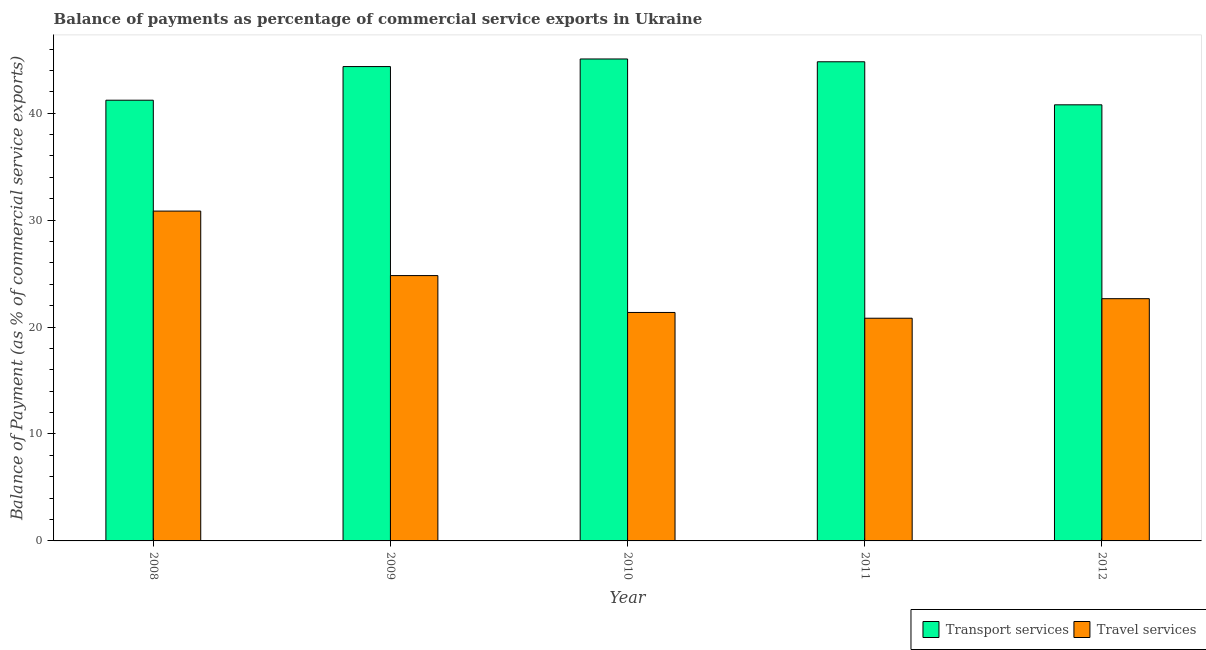How many groups of bars are there?
Offer a very short reply. 5. Are the number of bars on each tick of the X-axis equal?
Provide a succinct answer. Yes. In how many cases, is the number of bars for a given year not equal to the number of legend labels?
Offer a terse response. 0. What is the balance of payments of travel services in 2009?
Offer a very short reply. 24.81. Across all years, what is the maximum balance of payments of travel services?
Your response must be concise. 30.85. Across all years, what is the minimum balance of payments of transport services?
Your answer should be very brief. 40.79. In which year was the balance of payments of transport services maximum?
Provide a succinct answer. 2010. In which year was the balance of payments of transport services minimum?
Give a very brief answer. 2012. What is the total balance of payments of travel services in the graph?
Keep it short and to the point. 120.51. What is the difference between the balance of payments of transport services in 2008 and that in 2010?
Your response must be concise. -3.86. What is the difference between the balance of payments of travel services in 2012 and the balance of payments of transport services in 2008?
Make the answer very short. -8.19. What is the average balance of payments of travel services per year?
Your answer should be very brief. 24.1. In the year 2011, what is the difference between the balance of payments of travel services and balance of payments of transport services?
Your answer should be very brief. 0. In how many years, is the balance of payments of transport services greater than 10 %?
Provide a short and direct response. 5. What is the ratio of the balance of payments of travel services in 2008 to that in 2012?
Give a very brief answer. 1.36. Is the difference between the balance of payments of travel services in 2009 and 2011 greater than the difference between the balance of payments of transport services in 2009 and 2011?
Your answer should be very brief. No. What is the difference between the highest and the second highest balance of payments of transport services?
Provide a short and direct response. 0.26. What is the difference between the highest and the lowest balance of payments of transport services?
Provide a short and direct response. 4.29. Is the sum of the balance of payments of travel services in 2008 and 2012 greater than the maximum balance of payments of transport services across all years?
Provide a succinct answer. Yes. What does the 2nd bar from the left in 2008 represents?
Provide a succinct answer. Travel services. What does the 1st bar from the right in 2011 represents?
Offer a terse response. Travel services. Are all the bars in the graph horizontal?
Provide a succinct answer. No. Where does the legend appear in the graph?
Your answer should be compact. Bottom right. How many legend labels are there?
Ensure brevity in your answer.  2. How are the legend labels stacked?
Your response must be concise. Horizontal. What is the title of the graph?
Make the answer very short. Balance of payments as percentage of commercial service exports in Ukraine. Does "Private funds" appear as one of the legend labels in the graph?
Offer a terse response. No. What is the label or title of the X-axis?
Give a very brief answer. Year. What is the label or title of the Y-axis?
Offer a very short reply. Balance of Payment (as % of commercial service exports). What is the Balance of Payment (as % of commercial service exports) in Transport services in 2008?
Your response must be concise. 41.22. What is the Balance of Payment (as % of commercial service exports) of Travel services in 2008?
Provide a succinct answer. 30.85. What is the Balance of Payment (as % of commercial service exports) in Transport services in 2009?
Offer a very short reply. 44.36. What is the Balance of Payment (as % of commercial service exports) of Travel services in 2009?
Ensure brevity in your answer.  24.81. What is the Balance of Payment (as % of commercial service exports) of Transport services in 2010?
Offer a very short reply. 45.07. What is the Balance of Payment (as % of commercial service exports) of Travel services in 2010?
Give a very brief answer. 21.37. What is the Balance of Payment (as % of commercial service exports) in Transport services in 2011?
Keep it short and to the point. 44.81. What is the Balance of Payment (as % of commercial service exports) in Travel services in 2011?
Your answer should be very brief. 20.83. What is the Balance of Payment (as % of commercial service exports) in Transport services in 2012?
Your response must be concise. 40.79. What is the Balance of Payment (as % of commercial service exports) in Travel services in 2012?
Your answer should be very brief. 22.65. Across all years, what is the maximum Balance of Payment (as % of commercial service exports) in Transport services?
Keep it short and to the point. 45.07. Across all years, what is the maximum Balance of Payment (as % of commercial service exports) of Travel services?
Your response must be concise. 30.85. Across all years, what is the minimum Balance of Payment (as % of commercial service exports) of Transport services?
Provide a succinct answer. 40.79. Across all years, what is the minimum Balance of Payment (as % of commercial service exports) of Travel services?
Provide a succinct answer. 20.83. What is the total Balance of Payment (as % of commercial service exports) of Transport services in the graph?
Make the answer very short. 216.25. What is the total Balance of Payment (as % of commercial service exports) in Travel services in the graph?
Provide a short and direct response. 120.51. What is the difference between the Balance of Payment (as % of commercial service exports) of Transport services in 2008 and that in 2009?
Your answer should be compact. -3.15. What is the difference between the Balance of Payment (as % of commercial service exports) of Travel services in 2008 and that in 2009?
Give a very brief answer. 6.03. What is the difference between the Balance of Payment (as % of commercial service exports) of Transport services in 2008 and that in 2010?
Offer a very short reply. -3.86. What is the difference between the Balance of Payment (as % of commercial service exports) of Travel services in 2008 and that in 2010?
Ensure brevity in your answer.  9.48. What is the difference between the Balance of Payment (as % of commercial service exports) in Transport services in 2008 and that in 2011?
Your answer should be compact. -3.59. What is the difference between the Balance of Payment (as % of commercial service exports) in Travel services in 2008 and that in 2011?
Your response must be concise. 10.02. What is the difference between the Balance of Payment (as % of commercial service exports) in Transport services in 2008 and that in 2012?
Give a very brief answer. 0.43. What is the difference between the Balance of Payment (as % of commercial service exports) in Travel services in 2008 and that in 2012?
Provide a succinct answer. 8.19. What is the difference between the Balance of Payment (as % of commercial service exports) in Transport services in 2009 and that in 2010?
Your response must be concise. -0.71. What is the difference between the Balance of Payment (as % of commercial service exports) of Travel services in 2009 and that in 2010?
Keep it short and to the point. 3.45. What is the difference between the Balance of Payment (as % of commercial service exports) of Transport services in 2009 and that in 2011?
Provide a short and direct response. -0.45. What is the difference between the Balance of Payment (as % of commercial service exports) of Travel services in 2009 and that in 2011?
Offer a terse response. 3.99. What is the difference between the Balance of Payment (as % of commercial service exports) of Transport services in 2009 and that in 2012?
Ensure brevity in your answer.  3.58. What is the difference between the Balance of Payment (as % of commercial service exports) of Travel services in 2009 and that in 2012?
Your response must be concise. 2.16. What is the difference between the Balance of Payment (as % of commercial service exports) of Transport services in 2010 and that in 2011?
Offer a very short reply. 0.26. What is the difference between the Balance of Payment (as % of commercial service exports) in Travel services in 2010 and that in 2011?
Provide a short and direct response. 0.54. What is the difference between the Balance of Payment (as % of commercial service exports) of Transport services in 2010 and that in 2012?
Ensure brevity in your answer.  4.29. What is the difference between the Balance of Payment (as % of commercial service exports) in Travel services in 2010 and that in 2012?
Offer a very short reply. -1.29. What is the difference between the Balance of Payment (as % of commercial service exports) in Transport services in 2011 and that in 2012?
Your answer should be compact. 4.03. What is the difference between the Balance of Payment (as % of commercial service exports) of Travel services in 2011 and that in 2012?
Offer a terse response. -1.83. What is the difference between the Balance of Payment (as % of commercial service exports) of Transport services in 2008 and the Balance of Payment (as % of commercial service exports) of Travel services in 2009?
Provide a succinct answer. 16.4. What is the difference between the Balance of Payment (as % of commercial service exports) in Transport services in 2008 and the Balance of Payment (as % of commercial service exports) in Travel services in 2010?
Provide a short and direct response. 19.85. What is the difference between the Balance of Payment (as % of commercial service exports) in Transport services in 2008 and the Balance of Payment (as % of commercial service exports) in Travel services in 2011?
Ensure brevity in your answer.  20.39. What is the difference between the Balance of Payment (as % of commercial service exports) of Transport services in 2008 and the Balance of Payment (as % of commercial service exports) of Travel services in 2012?
Your answer should be compact. 18.56. What is the difference between the Balance of Payment (as % of commercial service exports) of Transport services in 2009 and the Balance of Payment (as % of commercial service exports) of Travel services in 2010?
Offer a terse response. 23. What is the difference between the Balance of Payment (as % of commercial service exports) in Transport services in 2009 and the Balance of Payment (as % of commercial service exports) in Travel services in 2011?
Keep it short and to the point. 23.54. What is the difference between the Balance of Payment (as % of commercial service exports) in Transport services in 2009 and the Balance of Payment (as % of commercial service exports) in Travel services in 2012?
Provide a succinct answer. 21.71. What is the difference between the Balance of Payment (as % of commercial service exports) of Transport services in 2010 and the Balance of Payment (as % of commercial service exports) of Travel services in 2011?
Make the answer very short. 24.25. What is the difference between the Balance of Payment (as % of commercial service exports) of Transport services in 2010 and the Balance of Payment (as % of commercial service exports) of Travel services in 2012?
Your answer should be very brief. 22.42. What is the difference between the Balance of Payment (as % of commercial service exports) of Transport services in 2011 and the Balance of Payment (as % of commercial service exports) of Travel services in 2012?
Provide a succinct answer. 22.16. What is the average Balance of Payment (as % of commercial service exports) in Transport services per year?
Provide a succinct answer. 43.25. What is the average Balance of Payment (as % of commercial service exports) of Travel services per year?
Keep it short and to the point. 24.1. In the year 2008, what is the difference between the Balance of Payment (as % of commercial service exports) in Transport services and Balance of Payment (as % of commercial service exports) in Travel services?
Offer a very short reply. 10.37. In the year 2009, what is the difference between the Balance of Payment (as % of commercial service exports) of Transport services and Balance of Payment (as % of commercial service exports) of Travel services?
Offer a very short reply. 19.55. In the year 2010, what is the difference between the Balance of Payment (as % of commercial service exports) of Transport services and Balance of Payment (as % of commercial service exports) of Travel services?
Your answer should be very brief. 23.71. In the year 2011, what is the difference between the Balance of Payment (as % of commercial service exports) in Transport services and Balance of Payment (as % of commercial service exports) in Travel services?
Keep it short and to the point. 23.98. In the year 2012, what is the difference between the Balance of Payment (as % of commercial service exports) in Transport services and Balance of Payment (as % of commercial service exports) in Travel services?
Provide a short and direct response. 18.13. What is the ratio of the Balance of Payment (as % of commercial service exports) of Transport services in 2008 to that in 2009?
Your answer should be compact. 0.93. What is the ratio of the Balance of Payment (as % of commercial service exports) in Travel services in 2008 to that in 2009?
Offer a terse response. 1.24. What is the ratio of the Balance of Payment (as % of commercial service exports) in Transport services in 2008 to that in 2010?
Make the answer very short. 0.91. What is the ratio of the Balance of Payment (as % of commercial service exports) in Travel services in 2008 to that in 2010?
Your answer should be very brief. 1.44. What is the ratio of the Balance of Payment (as % of commercial service exports) of Transport services in 2008 to that in 2011?
Make the answer very short. 0.92. What is the ratio of the Balance of Payment (as % of commercial service exports) in Travel services in 2008 to that in 2011?
Your answer should be compact. 1.48. What is the ratio of the Balance of Payment (as % of commercial service exports) of Transport services in 2008 to that in 2012?
Offer a terse response. 1.01. What is the ratio of the Balance of Payment (as % of commercial service exports) in Travel services in 2008 to that in 2012?
Ensure brevity in your answer.  1.36. What is the ratio of the Balance of Payment (as % of commercial service exports) of Transport services in 2009 to that in 2010?
Offer a terse response. 0.98. What is the ratio of the Balance of Payment (as % of commercial service exports) in Travel services in 2009 to that in 2010?
Your response must be concise. 1.16. What is the ratio of the Balance of Payment (as % of commercial service exports) in Transport services in 2009 to that in 2011?
Make the answer very short. 0.99. What is the ratio of the Balance of Payment (as % of commercial service exports) in Travel services in 2009 to that in 2011?
Your response must be concise. 1.19. What is the ratio of the Balance of Payment (as % of commercial service exports) of Transport services in 2009 to that in 2012?
Provide a short and direct response. 1.09. What is the ratio of the Balance of Payment (as % of commercial service exports) in Travel services in 2009 to that in 2012?
Offer a very short reply. 1.1. What is the ratio of the Balance of Payment (as % of commercial service exports) of Transport services in 2010 to that in 2011?
Your answer should be very brief. 1.01. What is the ratio of the Balance of Payment (as % of commercial service exports) of Travel services in 2010 to that in 2011?
Give a very brief answer. 1.03. What is the ratio of the Balance of Payment (as % of commercial service exports) of Transport services in 2010 to that in 2012?
Ensure brevity in your answer.  1.11. What is the ratio of the Balance of Payment (as % of commercial service exports) of Travel services in 2010 to that in 2012?
Keep it short and to the point. 0.94. What is the ratio of the Balance of Payment (as % of commercial service exports) in Transport services in 2011 to that in 2012?
Keep it short and to the point. 1.1. What is the ratio of the Balance of Payment (as % of commercial service exports) in Travel services in 2011 to that in 2012?
Ensure brevity in your answer.  0.92. What is the difference between the highest and the second highest Balance of Payment (as % of commercial service exports) in Transport services?
Your answer should be very brief. 0.26. What is the difference between the highest and the second highest Balance of Payment (as % of commercial service exports) of Travel services?
Ensure brevity in your answer.  6.03. What is the difference between the highest and the lowest Balance of Payment (as % of commercial service exports) in Transport services?
Your answer should be very brief. 4.29. What is the difference between the highest and the lowest Balance of Payment (as % of commercial service exports) of Travel services?
Your answer should be compact. 10.02. 